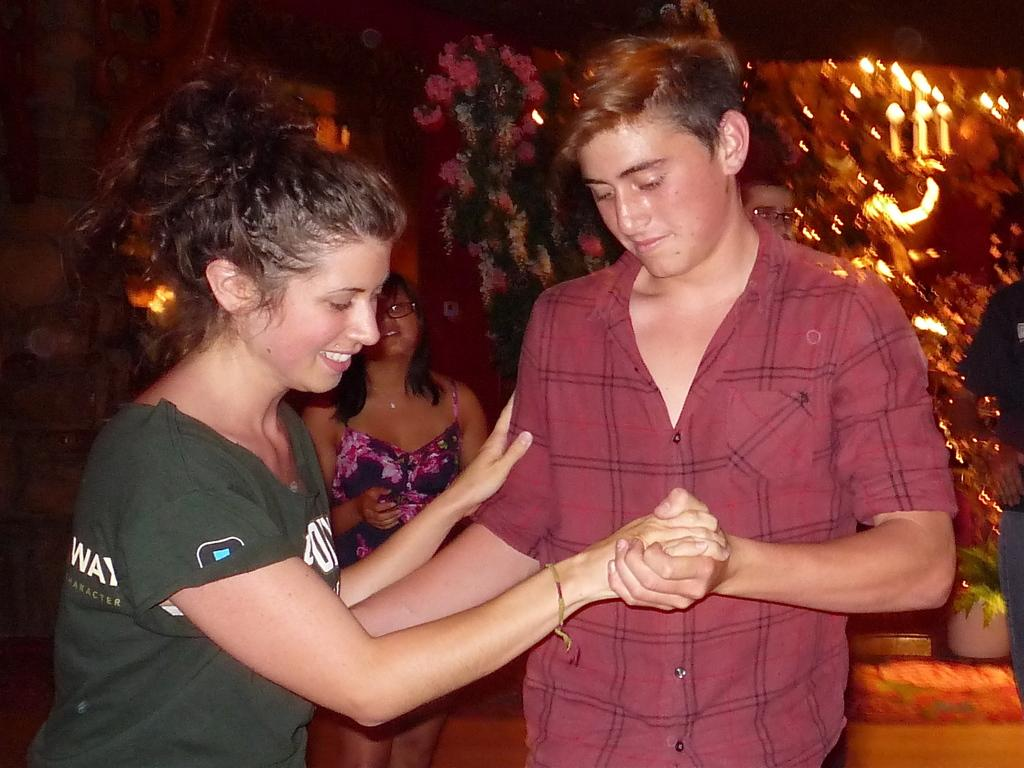Who are the two people in the image? There is a man and a woman in the image. What are the man and woman doing together? They are holding hands and dancing. Can you describe the setting of the image? There are people looking at them in the background, and there are lights and paintings on the walls. How many frames are there in the painting on the wall? There is no painting with a frame mentioned in the image. The paintings on the walls are not described in detail, so we cannot determine if any of them have frames. 